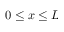Convert formula to latex. <formula><loc_0><loc_0><loc_500><loc_500>0 \leq x \leq L</formula> 